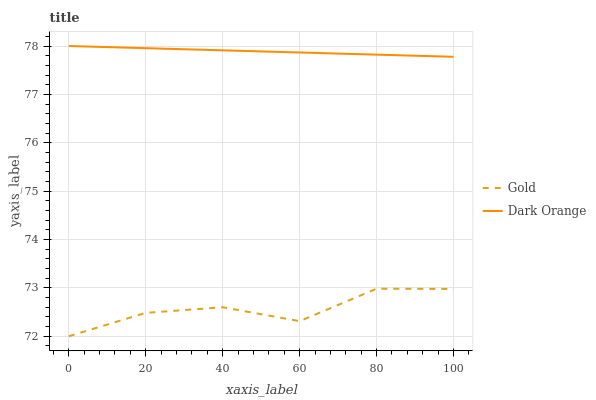Does Gold have the minimum area under the curve?
Answer yes or no. Yes. Does Dark Orange have the maximum area under the curve?
Answer yes or no. Yes. Does Gold have the maximum area under the curve?
Answer yes or no. No. Is Dark Orange the smoothest?
Answer yes or no. Yes. Is Gold the roughest?
Answer yes or no. Yes. Is Gold the smoothest?
Answer yes or no. No. Does Gold have the lowest value?
Answer yes or no. Yes. Does Dark Orange have the highest value?
Answer yes or no. Yes. Does Gold have the highest value?
Answer yes or no. No. Is Gold less than Dark Orange?
Answer yes or no. Yes. Is Dark Orange greater than Gold?
Answer yes or no. Yes. Does Gold intersect Dark Orange?
Answer yes or no. No. 